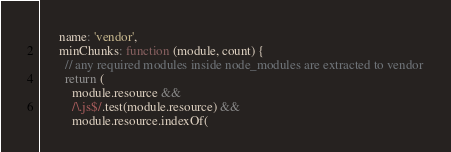<code> <loc_0><loc_0><loc_500><loc_500><_JavaScript_>      name: 'vendor',
      minChunks: function (module, count) {
        // any required modules inside node_modules are extracted to vendor
        return (
          module.resource &&
          /\.js$/.test(module.resource) &&
          module.resource.indexOf(</code> 